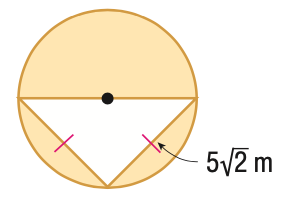Question: Find the area of the shaded region. Round to the nearest tenth.
Choices:
A. 25.0
B. 53.5
C. 78.5
D. 103.5
Answer with the letter. Answer: B 